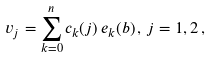<formula> <loc_0><loc_0><loc_500><loc_500>v _ { j } = \sum _ { k = 0 } ^ { n } c _ { k } ( j ) \, e _ { k } ( b ) \, , \, j = 1 , 2 \, ,</formula> 